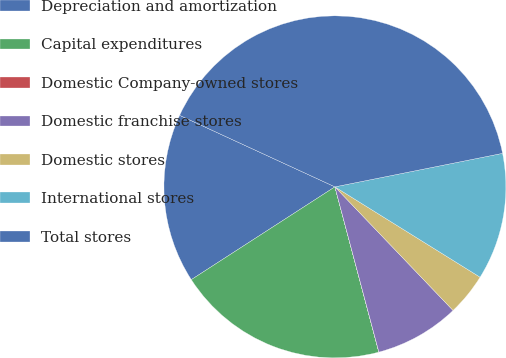Convert chart. <chart><loc_0><loc_0><loc_500><loc_500><pie_chart><fcel>Depreciation and amortization<fcel>Capital expenditures<fcel>Domestic Company-owned stores<fcel>Domestic franchise stores<fcel>Domestic stores<fcel>International stores<fcel>Total stores<nl><fcel>16.0%<fcel>20.0%<fcel>0.01%<fcel>8.0%<fcel>4.0%<fcel>12.0%<fcel>39.99%<nl></chart> 